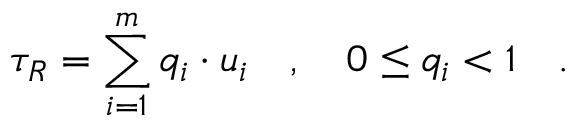<formula> <loc_0><loc_0><loc_500><loc_500>\tau _ { R } = \sum _ { i = 1 } ^ { m } q _ { i } \cdot u _ { i } \quad , \quad 0 \leq q _ { i } < 1 \quad .</formula> 